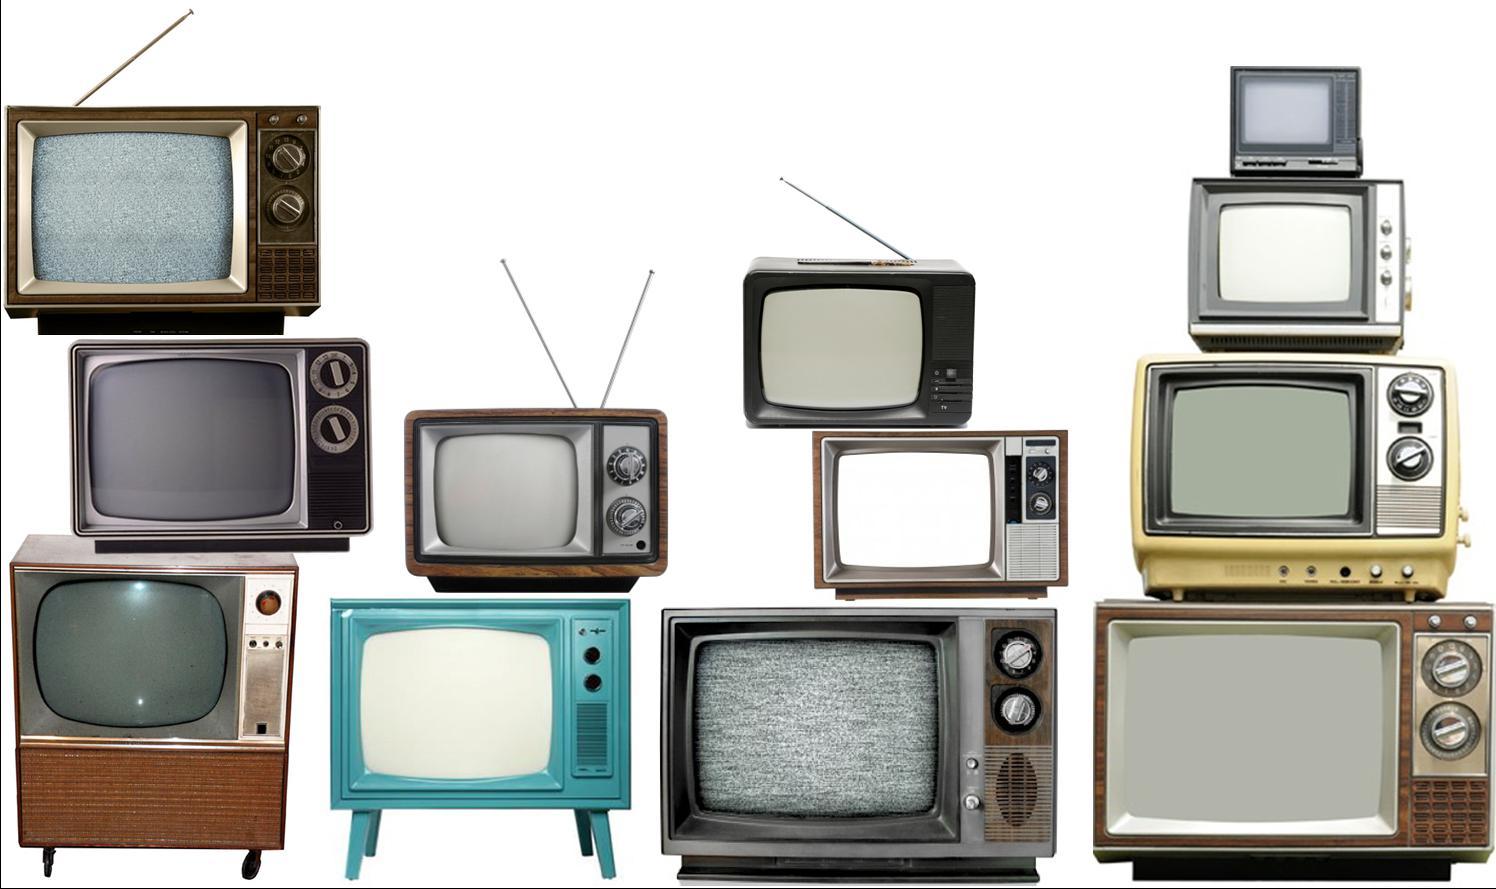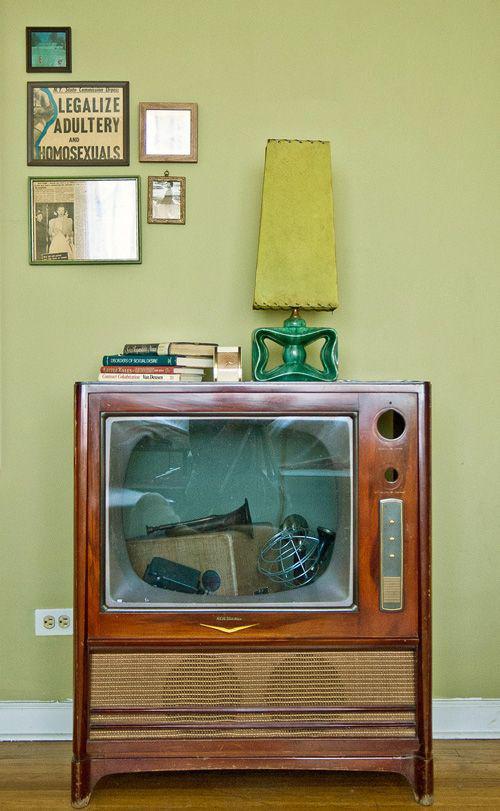The first image is the image on the left, the second image is the image on the right. Given the left and right images, does the statement "There is one tube type television in the image on the left." hold true? Answer yes or no. No. 